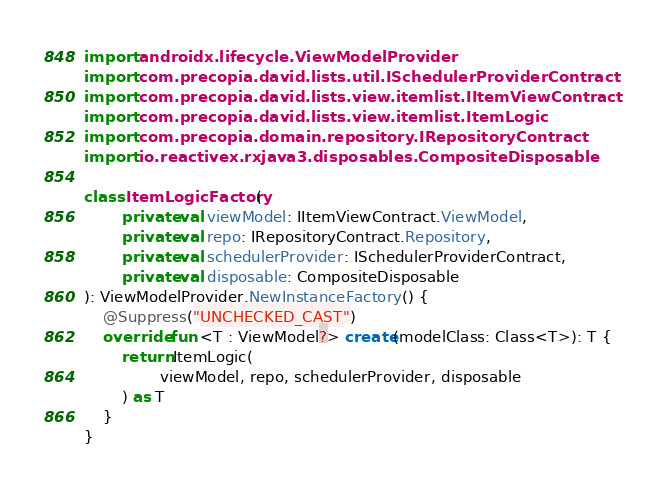Convert code to text. <code><loc_0><loc_0><loc_500><loc_500><_Kotlin_>import androidx.lifecycle.ViewModelProvider
import com.precopia.david.lists.util.ISchedulerProviderContract
import com.precopia.david.lists.view.itemlist.IItemViewContract
import com.precopia.david.lists.view.itemlist.ItemLogic
import com.precopia.domain.repository.IRepositoryContract
import io.reactivex.rxjava3.disposables.CompositeDisposable

class ItemLogicFactory(
        private val viewModel: IItemViewContract.ViewModel,
        private val repo: IRepositoryContract.Repository,
        private val schedulerProvider: ISchedulerProviderContract,
        private val disposable: CompositeDisposable
): ViewModelProvider.NewInstanceFactory() {
    @Suppress("UNCHECKED_CAST")
    override fun <T : ViewModel?> create(modelClass: Class<T>): T {
        return ItemLogic(
                viewModel, repo, schedulerProvider, disposable
        ) as T
    }
}</code> 